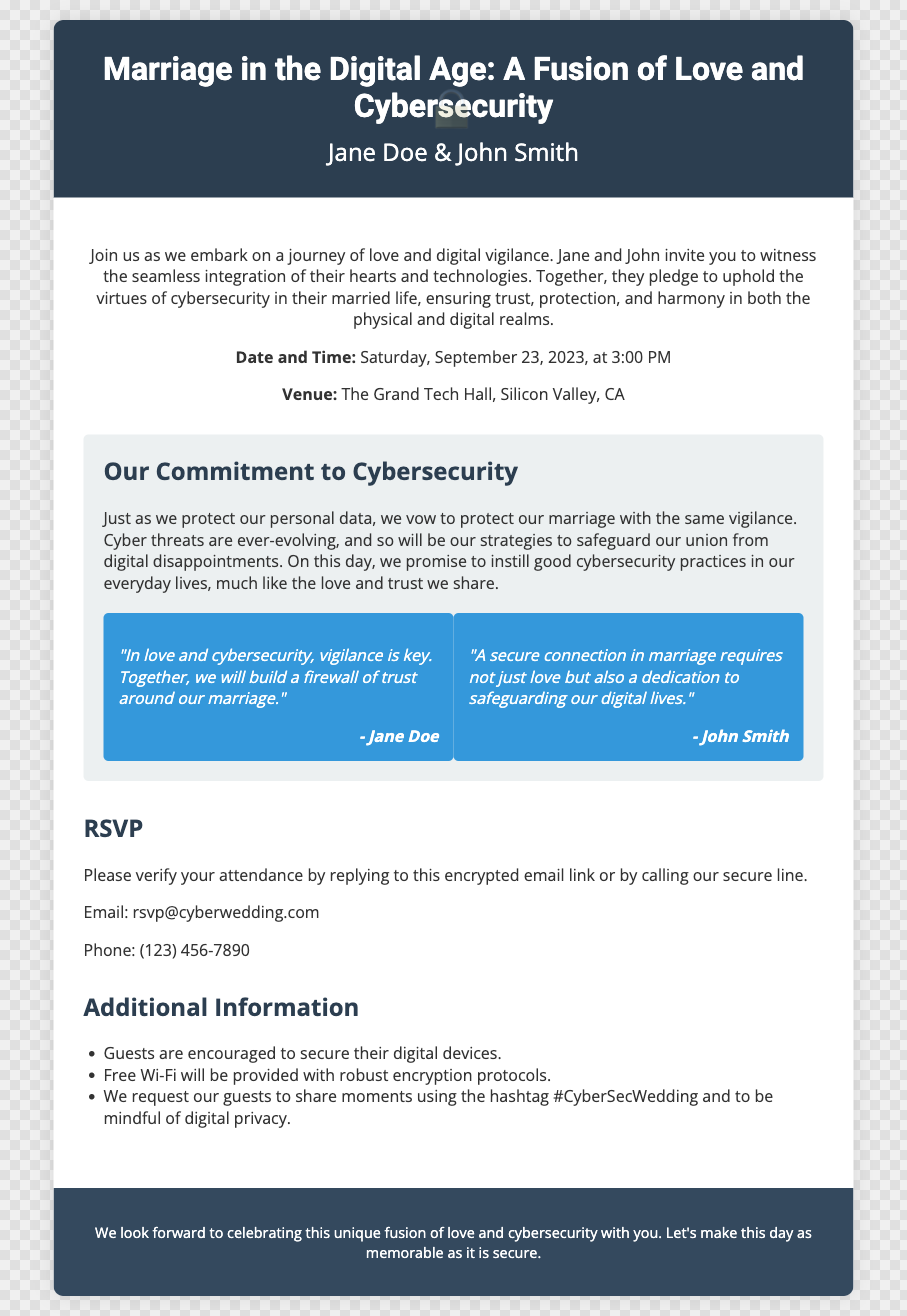What is the date of the wedding? The date of the wedding is explicitly mentioned in the invitation as "Saturday, September 23, 2023."
Answer: Saturday, September 23, 2023 What is the venue of the wedding? The invitation specifies the location as "The Grand Tech Hall, Silicon Valley, CA."
Answer: The Grand Tech Hall, Silicon Valley, CA Who are the couple getting married? The invitation clearly states the names of the couple as "Jane Doe & John Smith."
Answer: Jane Doe & John Smith What is one of the couple's commitments mentioned in the invitation? The invitation includes a statement about the couple's commitment to cybersecurity practices, indicating they will "vow to protect our marriage with the same vigilance."
Answer: Protect our marriage with the same vigilance How should guests secure their digital devices? The invitation encourages guests to "secure their digital devices," indicating a focus on cybersecurity during the event.
Answer: Secure their digital devices What is the RSVP email address? The invitation provides an email for RSVPs, stated as "rsvp@cyberwedding.com."
Answer: rsvp@cyberwedding.com What hashtag should guests use? The invitation requests guests to use the hashtag "#CyberSecWedding" while sharing moments from the event.
Answer: #CyberSecWedding Which font family is used in the document? The document includes a style section that imports specific font families, particularly "Roboto" and "Open Sans."
Answer: Roboto and Open Sans What does the couple promise regarding cybersecurity in their marriage? The couple promises to instill "good cybersecurity practices in our everyday lives" as part of their commitment.
Answer: Good cybersecurity practices in our everyday lives 